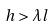Convert formula to latex. <formula><loc_0><loc_0><loc_500><loc_500>h > \lambda l</formula> 